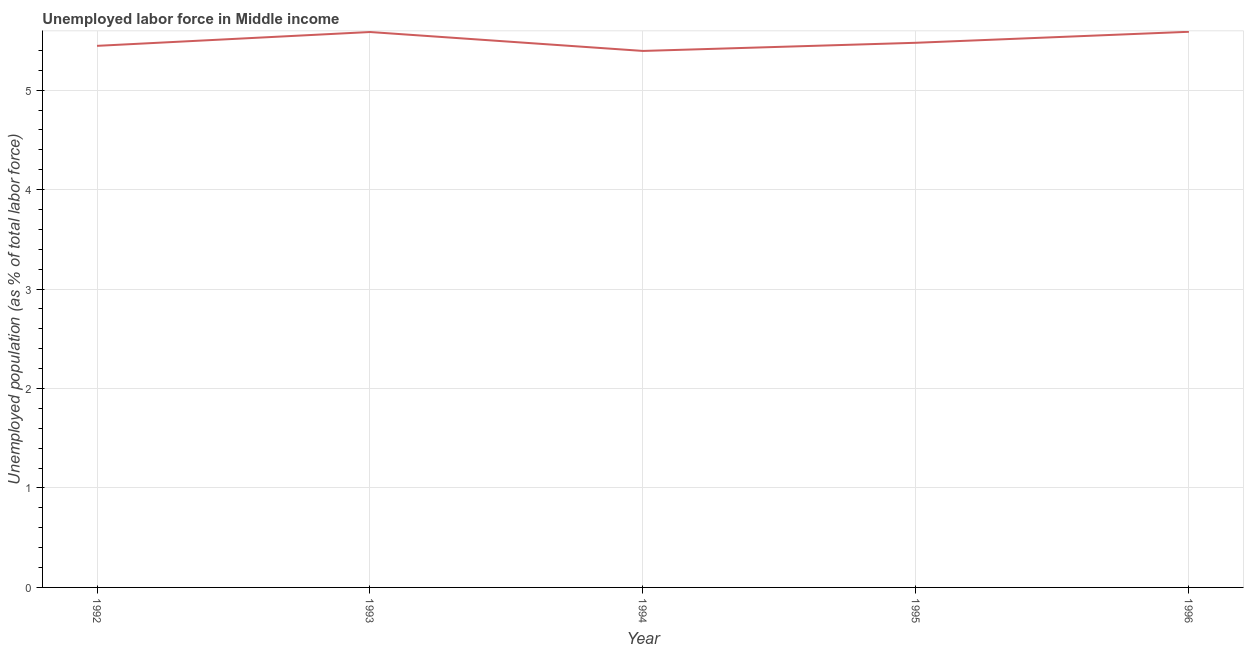What is the total unemployed population in 1996?
Offer a very short reply. 5.59. Across all years, what is the maximum total unemployed population?
Your response must be concise. 5.59. Across all years, what is the minimum total unemployed population?
Your answer should be very brief. 5.39. In which year was the total unemployed population minimum?
Your answer should be compact. 1994. What is the sum of the total unemployed population?
Offer a terse response. 27.49. What is the difference between the total unemployed population in 1994 and 1996?
Your answer should be very brief. -0.19. What is the average total unemployed population per year?
Provide a succinct answer. 5.5. What is the median total unemployed population?
Keep it short and to the point. 5.48. In how many years, is the total unemployed population greater than 1.4 %?
Keep it short and to the point. 5. What is the ratio of the total unemployed population in 1992 to that in 1995?
Give a very brief answer. 0.99. What is the difference between the highest and the second highest total unemployed population?
Make the answer very short. 0. Is the sum of the total unemployed population in 1992 and 1993 greater than the maximum total unemployed population across all years?
Your response must be concise. Yes. What is the difference between the highest and the lowest total unemployed population?
Your answer should be compact. 0.19. In how many years, is the total unemployed population greater than the average total unemployed population taken over all years?
Ensure brevity in your answer.  2. Are the values on the major ticks of Y-axis written in scientific E-notation?
Give a very brief answer. No. Does the graph contain any zero values?
Provide a succinct answer. No. Does the graph contain grids?
Your response must be concise. Yes. What is the title of the graph?
Make the answer very short. Unemployed labor force in Middle income. What is the label or title of the Y-axis?
Keep it short and to the point. Unemployed population (as % of total labor force). What is the Unemployed population (as % of total labor force) of 1992?
Your answer should be very brief. 5.45. What is the Unemployed population (as % of total labor force) of 1993?
Your answer should be very brief. 5.58. What is the Unemployed population (as % of total labor force) of 1994?
Ensure brevity in your answer.  5.39. What is the Unemployed population (as % of total labor force) in 1995?
Your answer should be very brief. 5.48. What is the Unemployed population (as % of total labor force) in 1996?
Offer a terse response. 5.59. What is the difference between the Unemployed population (as % of total labor force) in 1992 and 1993?
Your answer should be very brief. -0.14. What is the difference between the Unemployed population (as % of total labor force) in 1992 and 1994?
Your response must be concise. 0.05. What is the difference between the Unemployed population (as % of total labor force) in 1992 and 1995?
Make the answer very short. -0.03. What is the difference between the Unemployed population (as % of total labor force) in 1992 and 1996?
Make the answer very short. -0.14. What is the difference between the Unemployed population (as % of total labor force) in 1993 and 1994?
Provide a succinct answer. 0.19. What is the difference between the Unemployed population (as % of total labor force) in 1993 and 1995?
Offer a very short reply. 0.11. What is the difference between the Unemployed population (as % of total labor force) in 1993 and 1996?
Your answer should be very brief. -0. What is the difference between the Unemployed population (as % of total labor force) in 1994 and 1995?
Provide a succinct answer. -0.08. What is the difference between the Unemployed population (as % of total labor force) in 1994 and 1996?
Your answer should be compact. -0.19. What is the difference between the Unemployed population (as % of total labor force) in 1995 and 1996?
Offer a terse response. -0.11. What is the ratio of the Unemployed population (as % of total labor force) in 1992 to that in 1994?
Your answer should be very brief. 1.01. What is the ratio of the Unemployed population (as % of total labor force) in 1992 to that in 1995?
Your answer should be compact. 0.99. What is the ratio of the Unemployed population (as % of total labor force) in 1992 to that in 1996?
Ensure brevity in your answer.  0.97. What is the ratio of the Unemployed population (as % of total labor force) in 1993 to that in 1994?
Keep it short and to the point. 1.03. What is the ratio of the Unemployed population (as % of total labor force) in 1993 to that in 1996?
Give a very brief answer. 1. What is the ratio of the Unemployed population (as % of total labor force) in 1994 to that in 1995?
Provide a short and direct response. 0.98. What is the ratio of the Unemployed population (as % of total labor force) in 1994 to that in 1996?
Offer a terse response. 0.97. 